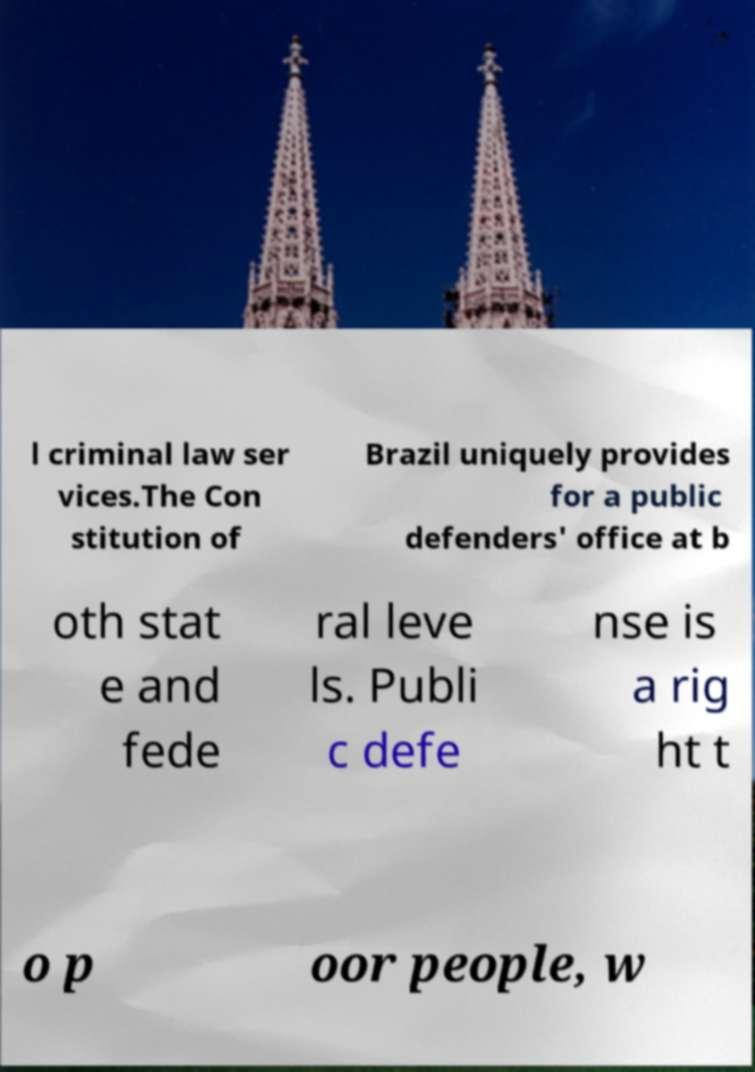There's text embedded in this image that I need extracted. Can you transcribe it verbatim? l criminal law ser vices.The Con stitution of Brazil uniquely provides for a public defenders' office at b oth stat e and fede ral leve ls. Publi c defe nse is a rig ht t o p oor people, w 